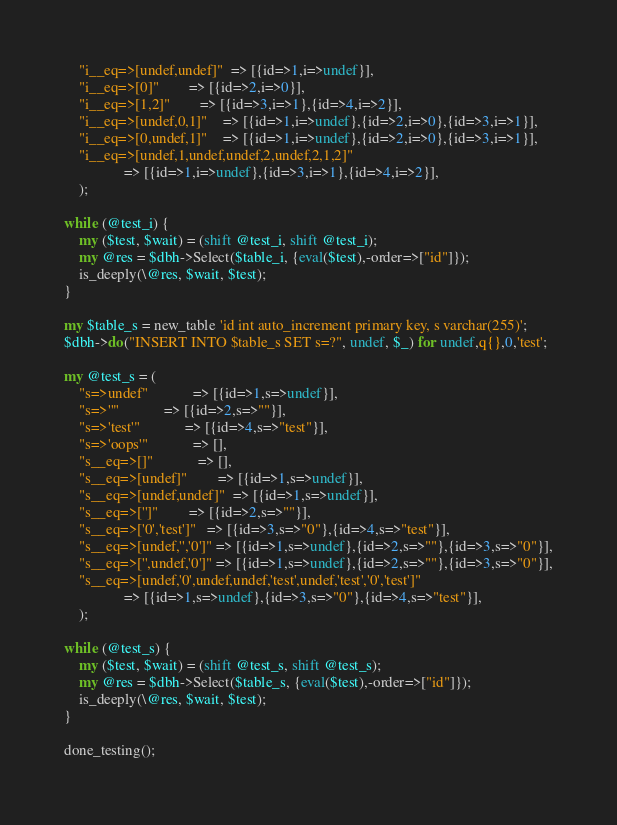Convert code to text. <code><loc_0><loc_0><loc_500><loc_500><_Perl_>    "i__eq=>[undef,undef]"  => [{id=>1,i=>undef}],
    "i__eq=>[0]"	    => [{id=>2,i=>0}],
    "i__eq=>[1,2]"	    => [{id=>3,i=>1},{id=>4,i=>2}],
    "i__eq=>[undef,0,1]"    => [{id=>1,i=>undef},{id=>2,i=>0},{id=>3,i=>1}],
    "i__eq=>[0,undef,1]"    => [{id=>1,i=>undef},{id=>2,i=>0},{id=>3,i=>1}],
    "i__eq=>[undef,1,undef,undef,2,undef,2,1,2]"
			    => [{id=>1,i=>undef},{id=>3,i=>1},{id=>4,i=>2}],
    );

while (@test_i) {
    my ($test, $wait) = (shift @test_i, shift @test_i);
    my @res = $dbh->Select($table_i, {eval($test),-order=>["id"]});
    is_deeply(\@res, $wait, $test);
}

my $table_s = new_table 'id int auto_increment primary key, s varchar(255)';
$dbh->do("INSERT INTO $table_s SET s=?", undef, $_) for undef,q{},0,'test';

my @test_s = (
    "s=>undef"		    => [{id=>1,s=>undef}],
    "s=>''"		    => [{id=>2,s=>""}],
    "s=>'test'"		    => [{id=>4,s=>"test"}],
    "s=>'oops'"		    => [],
    "s__eq=>[]"		    => [],
    "s__eq=>[undef]"	    => [{id=>1,s=>undef}],
    "s__eq=>[undef,undef]"  => [{id=>1,s=>undef}],
    "s__eq=>['']"	    => [{id=>2,s=>""}],
    "s__eq=>['0','test']"   => [{id=>3,s=>"0"},{id=>4,s=>"test"}],
    "s__eq=>[undef,'','0']" => [{id=>1,s=>undef},{id=>2,s=>""},{id=>3,s=>"0"}],
    "s__eq=>['',undef,'0']" => [{id=>1,s=>undef},{id=>2,s=>""},{id=>3,s=>"0"}],
    "s__eq=>[undef,'0',undef,undef,'test',undef,'test','0','test']"
			    => [{id=>1,s=>undef},{id=>3,s=>"0"},{id=>4,s=>"test"}],
    );

while (@test_s) {
    my ($test, $wait) = (shift @test_s, shift @test_s);
    my @res = $dbh->Select($table_s, {eval($test),-order=>["id"]});
    is_deeply(\@res, $wait, $test);
}

done_testing();
</code> 